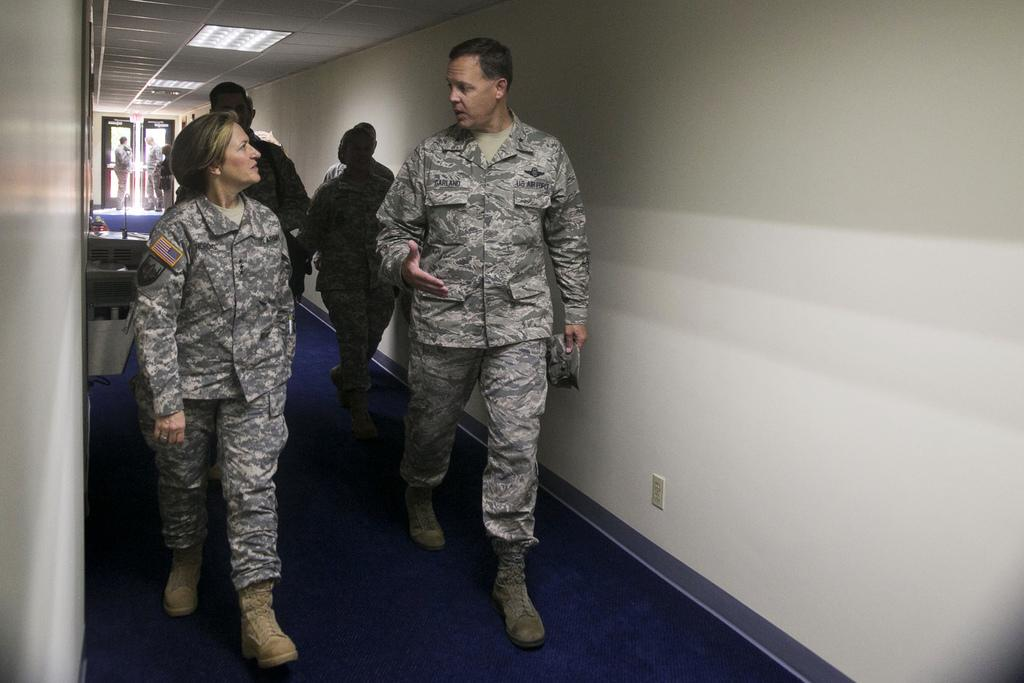What are the people in the image doing? The people in the image are walking. On what surface are the people walking? The people are walking on a floor. What can be seen on both sides of the floor? There is a wall on either side of the floor. What is above the floor in the image? There is a ceiling in the image. What provides illumination in the image? There are lights visible in the image. What type of animal is being trained to expand the glove in the image? There is no animal or glove present in the image; it features people walking on a floor with walls and a ceiling. 